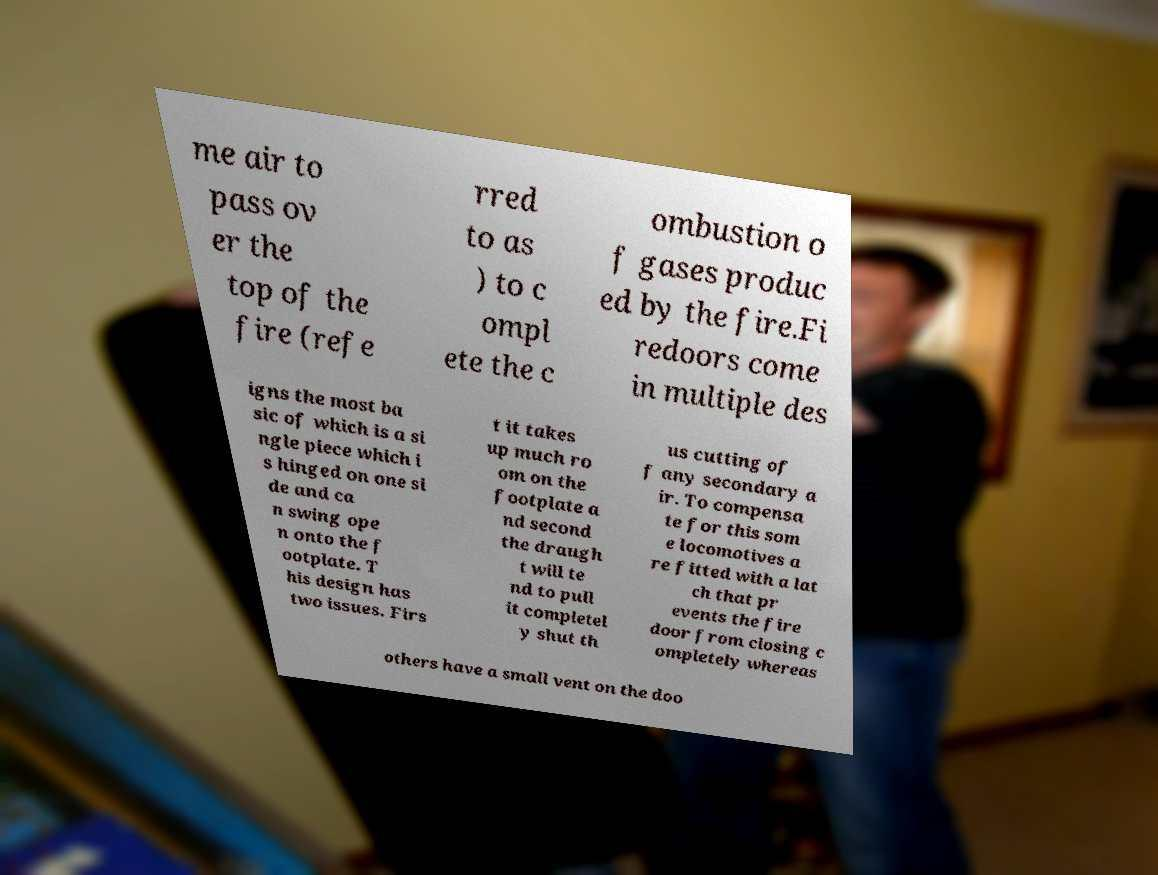There's text embedded in this image that I need extracted. Can you transcribe it verbatim? me air to pass ov er the top of the fire (refe rred to as ) to c ompl ete the c ombustion o f gases produc ed by the fire.Fi redoors come in multiple des igns the most ba sic of which is a si ngle piece which i s hinged on one si de and ca n swing ope n onto the f ootplate. T his design has two issues. Firs t it takes up much ro om on the footplate a nd second the draugh t will te nd to pull it completel y shut th us cutting of f any secondary a ir. To compensa te for this som e locomotives a re fitted with a lat ch that pr events the fire door from closing c ompletely whereas others have a small vent on the doo 